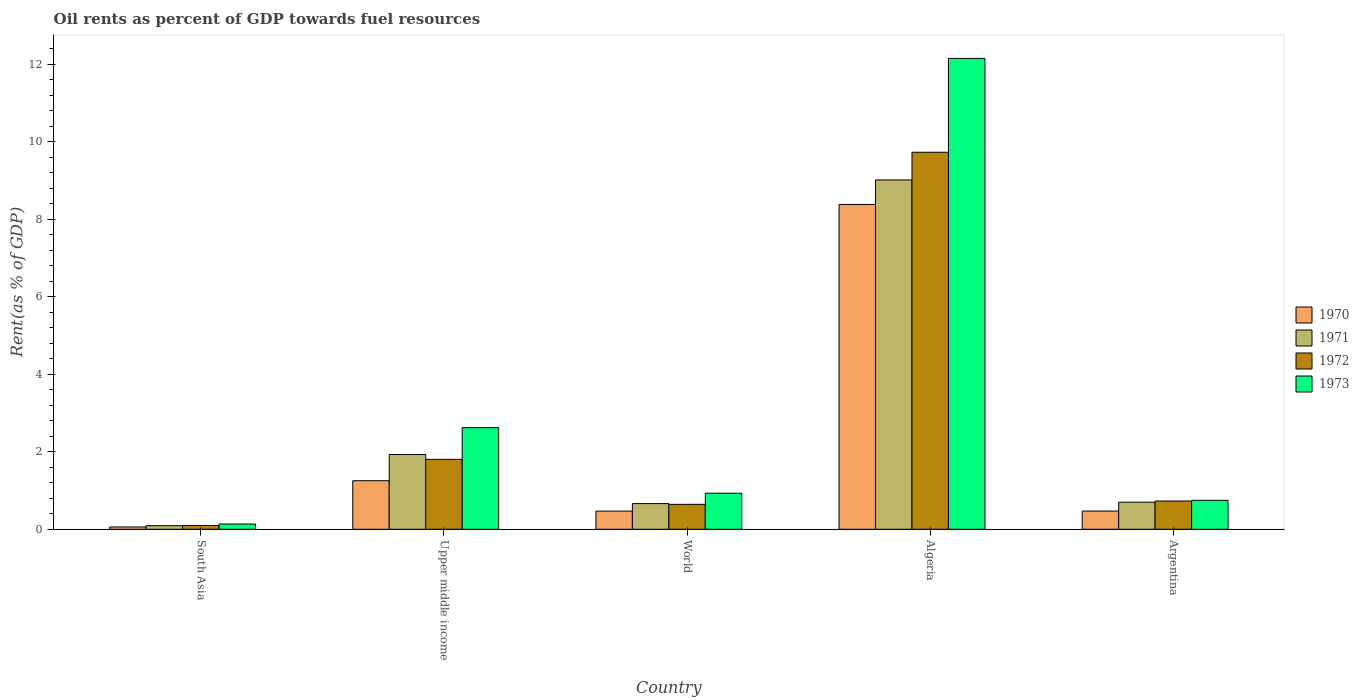What is the label of the 4th group of bars from the left?
Your response must be concise. Algeria. What is the oil rent in 1972 in South Asia?
Keep it short and to the point. 0.1. Across all countries, what is the maximum oil rent in 1973?
Offer a terse response. 12.15. Across all countries, what is the minimum oil rent in 1973?
Your response must be concise. 0.14. In which country was the oil rent in 1970 maximum?
Your response must be concise. Algeria. What is the total oil rent in 1972 in the graph?
Make the answer very short. 13.01. What is the difference between the oil rent in 1970 in Argentina and that in Upper middle income?
Make the answer very short. -0.78. What is the difference between the oil rent in 1971 in Argentina and the oil rent in 1973 in Algeria?
Provide a short and direct response. -11.45. What is the average oil rent in 1973 per country?
Offer a very short reply. 3.32. What is the difference between the oil rent of/in 1973 and oil rent of/in 1972 in South Asia?
Provide a short and direct response. 0.04. In how many countries, is the oil rent in 1972 greater than 4.4 %?
Offer a very short reply. 1. What is the ratio of the oil rent in 1971 in Algeria to that in Argentina?
Keep it short and to the point. 12.88. What is the difference between the highest and the second highest oil rent in 1971?
Provide a short and direct response. -8.32. What is the difference between the highest and the lowest oil rent in 1971?
Offer a terse response. 8.92. Is the sum of the oil rent in 1970 in Argentina and South Asia greater than the maximum oil rent in 1973 across all countries?
Provide a short and direct response. No. Is it the case that in every country, the sum of the oil rent in 1973 and oil rent in 1971 is greater than the sum of oil rent in 1972 and oil rent in 1970?
Provide a short and direct response. No. What does the 4th bar from the right in Algeria represents?
Your answer should be compact. 1970. How many bars are there?
Provide a succinct answer. 20. How many countries are there in the graph?
Provide a succinct answer. 5. What is the difference between two consecutive major ticks on the Y-axis?
Offer a very short reply. 2. Are the values on the major ticks of Y-axis written in scientific E-notation?
Keep it short and to the point. No. Does the graph contain any zero values?
Provide a short and direct response. No. Where does the legend appear in the graph?
Offer a very short reply. Center right. How many legend labels are there?
Provide a succinct answer. 4. How are the legend labels stacked?
Provide a short and direct response. Vertical. What is the title of the graph?
Ensure brevity in your answer.  Oil rents as percent of GDP towards fuel resources. What is the label or title of the Y-axis?
Provide a succinct answer. Rent(as % of GDP). What is the Rent(as % of GDP) in 1970 in South Asia?
Ensure brevity in your answer.  0.06. What is the Rent(as % of GDP) of 1971 in South Asia?
Your response must be concise. 0.09. What is the Rent(as % of GDP) of 1972 in South Asia?
Make the answer very short. 0.1. What is the Rent(as % of GDP) of 1973 in South Asia?
Keep it short and to the point. 0.14. What is the Rent(as % of GDP) in 1970 in Upper middle income?
Offer a terse response. 1.25. What is the Rent(as % of GDP) in 1971 in Upper middle income?
Ensure brevity in your answer.  1.93. What is the Rent(as % of GDP) in 1972 in Upper middle income?
Your answer should be very brief. 1.8. What is the Rent(as % of GDP) in 1973 in Upper middle income?
Offer a terse response. 2.62. What is the Rent(as % of GDP) of 1970 in World?
Provide a short and direct response. 0.47. What is the Rent(as % of GDP) in 1971 in World?
Keep it short and to the point. 0.66. What is the Rent(as % of GDP) of 1972 in World?
Ensure brevity in your answer.  0.64. What is the Rent(as % of GDP) of 1973 in World?
Make the answer very short. 0.93. What is the Rent(as % of GDP) in 1970 in Algeria?
Provide a short and direct response. 8.38. What is the Rent(as % of GDP) in 1971 in Algeria?
Offer a very short reply. 9.02. What is the Rent(as % of GDP) of 1972 in Algeria?
Provide a short and direct response. 9.73. What is the Rent(as % of GDP) in 1973 in Algeria?
Offer a very short reply. 12.15. What is the Rent(as % of GDP) of 1970 in Argentina?
Make the answer very short. 0.47. What is the Rent(as % of GDP) in 1971 in Argentina?
Offer a terse response. 0.7. What is the Rent(as % of GDP) in 1972 in Argentina?
Make the answer very short. 0.73. What is the Rent(as % of GDP) in 1973 in Argentina?
Provide a succinct answer. 0.75. Across all countries, what is the maximum Rent(as % of GDP) of 1970?
Provide a succinct answer. 8.38. Across all countries, what is the maximum Rent(as % of GDP) of 1971?
Your response must be concise. 9.02. Across all countries, what is the maximum Rent(as % of GDP) of 1972?
Keep it short and to the point. 9.73. Across all countries, what is the maximum Rent(as % of GDP) in 1973?
Your answer should be compact. 12.15. Across all countries, what is the minimum Rent(as % of GDP) of 1970?
Provide a succinct answer. 0.06. Across all countries, what is the minimum Rent(as % of GDP) of 1971?
Give a very brief answer. 0.09. Across all countries, what is the minimum Rent(as % of GDP) in 1972?
Keep it short and to the point. 0.1. Across all countries, what is the minimum Rent(as % of GDP) of 1973?
Your answer should be compact. 0.14. What is the total Rent(as % of GDP) in 1970 in the graph?
Ensure brevity in your answer.  10.64. What is the total Rent(as % of GDP) in 1971 in the graph?
Provide a succinct answer. 12.4. What is the total Rent(as % of GDP) of 1972 in the graph?
Ensure brevity in your answer.  13.01. What is the total Rent(as % of GDP) of 1973 in the graph?
Offer a very short reply. 16.59. What is the difference between the Rent(as % of GDP) of 1970 in South Asia and that in Upper middle income?
Make the answer very short. -1.19. What is the difference between the Rent(as % of GDP) in 1971 in South Asia and that in Upper middle income?
Provide a succinct answer. -1.84. What is the difference between the Rent(as % of GDP) of 1972 in South Asia and that in Upper middle income?
Provide a succinct answer. -1.71. What is the difference between the Rent(as % of GDP) in 1973 in South Asia and that in Upper middle income?
Your answer should be very brief. -2.49. What is the difference between the Rent(as % of GDP) of 1970 in South Asia and that in World?
Your answer should be very brief. -0.41. What is the difference between the Rent(as % of GDP) in 1971 in South Asia and that in World?
Your response must be concise. -0.57. What is the difference between the Rent(as % of GDP) in 1972 in South Asia and that in World?
Offer a very short reply. -0.55. What is the difference between the Rent(as % of GDP) in 1973 in South Asia and that in World?
Offer a very short reply. -0.8. What is the difference between the Rent(as % of GDP) of 1970 in South Asia and that in Algeria?
Make the answer very short. -8.32. What is the difference between the Rent(as % of GDP) in 1971 in South Asia and that in Algeria?
Your response must be concise. -8.92. What is the difference between the Rent(as % of GDP) in 1972 in South Asia and that in Algeria?
Ensure brevity in your answer.  -9.63. What is the difference between the Rent(as % of GDP) of 1973 in South Asia and that in Algeria?
Your answer should be very brief. -12.02. What is the difference between the Rent(as % of GDP) in 1970 in South Asia and that in Argentina?
Offer a terse response. -0.41. What is the difference between the Rent(as % of GDP) of 1971 in South Asia and that in Argentina?
Provide a succinct answer. -0.61. What is the difference between the Rent(as % of GDP) of 1972 in South Asia and that in Argentina?
Provide a succinct answer. -0.63. What is the difference between the Rent(as % of GDP) in 1973 in South Asia and that in Argentina?
Provide a short and direct response. -0.61. What is the difference between the Rent(as % of GDP) of 1970 in Upper middle income and that in World?
Provide a succinct answer. 0.78. What is the difference between the Rent(as % of GDP) in 1971 in Upper middle income and that in World?
Make the answer very short. 1.27. What is the difference between the Rent(as % of GDP) in 1972 in Upper middle income and that in World?
Provide a succinct answer. 1.16. What is the difference between the Rent(as % of GDP) in 1973 in Upper middle income and that in World?
Offer a very short reply. 1.69. What is the difference between the Rent(as % of GDP) of 1970 in Upper middle income and that in Algeria?
Provide a short and direct response. -7.13. What is the difference between the Rent(as % of GDP) in 1971 in Upper middle income and that in Algeria?
Ensure brevity in your answer.  -7.09. What is the difference between the Rent(as % of GDP) in 1972 in Upper middle income and that in Algeria?
Offer a very short reply. -7.93. What is the difference between the Rent(as % of GDP) of 1973 in Upper middle income and that in Algeria?
Your answer should be very brief. -9.53. What is the difference between the Rent(as % of GDP) of 1970 in Upper middle income and that in Argentina?
Make the answer very short. 0.78. What is the difference between the Rent(as % of GDP) in 1971 in Upper middle income and that in Argentina?
Offer a very short reply. 1.23. What is the difference between the Rent(as % of GDP) in 1972 in Upper middle income and that in Argentina?
Provide a short and direct response. 1.07. What is the difference between the Rent(as % of GDP) of 1973 in Upper middle income and that in Argentina?
Ensure brevity in your answer.  1.88. What is the difference between the Rent(as % of GDP) of 1970 in World and that in Algeria?
Provide a succinct answer. -7.91. What is the difference between the Rent(as % of GDP) of 1971 in World and that in Algeria?
Your answer should be very brief. -8.35. What is the difference between the Rent(as % of GDP) in 1972 in World and that in Algeria?
Your response must be concise. -9.09. What is the difference between the Rent(as % of GDP) in 1973 in World and that in Algeria?
Offer a terse response. -11.22. What is the difference between the Rent(as % of GDP) of 1970 in World and that in Argentina?
Keep it short and to the point. -0. What is the difference between the Rent(as % of GDP) in 1971 in World and that in Argentina?
Your answer should be very brief. -0.04. What is the difference between the Rent(as % of GDP) in 1972 in World and that in Argentina?
Offer a very short reply. -0.09. What is the difference between the Rent(as % of GDP) in 1973 in World and that in Argentina?
Provide a succinct answer. 0.18. What is the difference between the Rent(as % of GDP) of 1970 in Algeria and that in Argentina?
Provide a succinct answer. 7.91. What is the difference between the Rent(as % of GDP) of 1971 in Algeria and that in Argentina?
Ensure brevity in your answer.  8.32. What is the difference between the Rent(as % of GDP) in 1972 in Algeria and that in Argentina?
Your answer should be compact. 9. What is the difference between the Rent(as % of GDP) in 1973 in Algeria and that in Argentina?
Your answer should be very brief. 11.41. What is the difference between the Rent(as % of GDP) of 1970 in South Asia and the Rent(as % of GDP) of 1971 in Upper middle income?
Your response must be concise. -1.87. What is the difference between the Rent(as % of GDP) of 1970 in South Asia and the Rent(as % of GDP) of 1972 in Upper middle income?
Your answer should be very brief. -1.74. What is the difference between the Rent(as % of GDP) of 1970 in South Asia and the Rent(as % of GDP) of 1973 in Upper middle income?
Your answer should be compact. -2.56. What is the difference between the Rent(as % of GDP) in 1971 in South Asia and the Rent(as % of GDP) in 1972 in Upper middle income?
Your answer should be compact. -1.71. What is the difference between the Rent(as % of GDP) of 1971 in South Asia and the Rent(as % of GDP) of 1973 in Upper middle income?
Offer a terse response. -2.53. What is the difference between the Rent(as % of GDP) of 1972 in South Asia and the Rent(as % of GDP) of 1973 in Upper middle income?
Provide a short and direct response. -2.52. What is the difference between the Rent(as % of GDP) of 1970 in South Asia and the Rent(as % of GDP) of 1971 in World?
Your answer should be compact. -0.6. What is the difference between the Rent(as % of GDP) of 1970 in South Asia and the Rent(as % of GDP) of 1972 in World?
Make the answer very short. -0.58. What is the difference between the Rent(as % of GDP) of 1970 in South Asia and the Rent(as % of GDP) of 1973 in World?
Give a very brief answer. -0.87. What is the difference between the Rent(as % of GDP) of 1971 in South Asia and the Rent(as % of GDP) of 1972 in World?
Provide a succinct answer. -0.55. What is the difference between the Rent(as % of GDP) in 1971 in South Asia and the Rent(as % of GDP) in 1973 in World?
Keep it short and to the point. -0.84. What is the difference between the Rent(as % of GDP) of 1972 in South Asia and the Rent(as % of GDP) of 1973 in World?
Keep it short and to the point. -0.83. What is the difference between the Rent(as % of GDP) of 1970 in South Asia and the Rent(as % of GDP) of 1971 in Algeria?
Make the answer very short. -8.96. What is the difference between the Rent(as % of GDP) of 1970 in South Asia and the Rent(as % of GDP) of 1972 in Algeria?
Offer a terse response. -9.67. What is the difference between the Rent(as % of GDP) in 1970 in South Asia and the Rent(as % of GDP) in 1973 in Algeria?
Make the answer very short. -12.09. What is the difference between the Rent(as % of GDP) in 1971 in South Asia and the Rent(as % of GDP) in 1972 in Algeria?
Provide a succinct answer. -9.64. What is the difference between the Rent(as % of GDP) of 1971 in South Asia and the Rent(as % of GDP) of 1973 in Algeria?
Offer a very short reply. -12.06. What is the difference between the Rent(as % of GDP) in 1972 in South Asia and the Rent(as % of GDP) in 1973 in Algeria?
Ensure brevity in your answer.  -12.05. What is the difference between the Rent(as % of GDP) of 1970 in South Asia and the Rent(as % of GDP) of 1971 in Argentina?
Provide a succinct answer. -0.64. What is the difference between the Rent(as % of GDP) of 1970 in South Asia and the Rent(as % of GDP) of 1972 in Argentina?
Provide a short and direct response. -0.67. What is the difference between the Rent(as % of GDP) in 1970 in South Asia and the Rent(as % of GDP) in 1973 in Argentina?
Your answer should be compact. -0.69. What is the difference between the Rent(as % of GDP) of 1971 in South Asia and the Rent(as % of GDP) of 1972 in Argentina?
Offer a terse response. -0.64. What is the difference between the Rent(as % of GDP) of 1971 in South Asia and the Rent(as % of GDP) of 1973 in Argentina?
Make the answer very short. -0.65. What is the difference between the Rent(as % of GDP) in 1972 in South Asia and the Rent(as % of GDP) in 1973 in Argentina?
Keep it short and to the point. -0.65. What is the difference between the Rent(as % of GDP) in 1970 in Upper middle income and the Rent(as % of GDP) in 1971 in World?
Keep it short and to the point. 0.59. What is the difference between the Rent(as % of GDP) of 1970 in Upper middle income and the Rent(as % of GDP) of 1972 in World?
Provide a succinct answer. 0.61. What is the difference between the Rent(as % of GDP) in 1970 in Upper middle income and the Rent(as % of GDP) in 1973 in World?
Give a very brief answer. 0.32. What is the difference between the Rent(as % of GDP) of 1971 in Upper middle income and the Rent(as % of GDP) of 1972 in World?
Provide a short and direct response. 1.29. What is the difference between the Rent(as % of GDP) of 1971 in Upper middle income and the Rent(as % of GDP) of 1973 in World?
Offer a very short reply. 1. What is the difference between the Rent(as % of GDP) of 1972 in Upper middle income and the Rent(as % of GDP) of 1973 in World?
Your response must be concise. 0.87. What is the difference between the Rent(as % of GDP) in 1970 in Upper middle income and the Rent(as % of GDP) in 1971 in Algeria?
Provide a short and direct response. -7.76. What is the difference between the Rent(as % of GDP) of 1970 in Upper middle income and the Rent(as % of GDP) of 1972 in Algeria?
Your response must be concise. -8.48. What is the difference between the Rent(as % of GDP) of 1970 in Upper middle income and the Rent(as % of GDP) of 1973 in Algeria?
Your response must be concise. -10.9. What is the difference between the Rent(as % of GDP) in 1971 in Upper middle income and the Rent(as % of GDP) in 1973 in Algeria?
Keep it short and to the point. -10.22. What is the difference between the Rent(as % of GDP) in 1972 in Upper middle income and the Rent(as % of GDP) in 1973 in Algeria?
Provide a short and direct response. -10.35. What is the difference between the Rent(as % of GDP) in 1970 in Upper middle income and the Rent(as % of GDP) in 1971 in Argentina?
Keep it short and to the point. 0.55. What is the difference between the Rent(as % of GDP) of 1970 in Upper middle income and the Rent(as % of GDP) of 1972 in Argentina?
Give a very brief answer. 0.52. What is the difference between the Rent(as % of GDP) in 1970 in Upper middle income and the Rent(as % of GDP) in 1973 in Argentina?
Ensure brevity in your answer.  0.51. What is the difference between the Rent(as % of GDP) in 1971 in Upper middle income and the Rent(as % of GDP) in 1972 in Argentina?
Offer a terse response. 1.2. What is the difference between the Rent(as % of GDP) in 1971 in Upper middle income and the Rent(as % of GDP) in 1973 in Argentina?
Your answer should be very brief. 1.18. What is the difference between the Rent(as % of GDP) in 1972 in Upper middle income and the Rent(as % of GDP) in 1973 in Argentina?
Your answer should be compact. 1.06. What is the difference between the Rent(as % of GDP) of 1970 in World and the Rent(as % of GDP) of 1971 in Algeria?
Your answer should be very brief. -8.55. What is the difference between the Rent(as % of GDP) of 1970 in World and the Rent(as % of GDP) of 1972 in Algeria?
Ensure brevity in your answer.  -9.26. What is the difference between the Rent(as % of GDP) in 1970 in World and the Rent(as % of GDP) in 1973 in Algeria?
Make the answer very short. -11.68. What is the difference between the Rent(as % of GDP) of 1971 in World and the Rent(as % of GDP) of 1972 in Algeria?
Your answer should be compact. -9.07. What is the difference between the Rent(as % of GDP) of 1971 in World and the Rent(as % of GDP) of 1973 in Algeria?
Offer a terse response. -11.49. What is the difference between the Rent(as % of GDP) of 1972 in World and the Rent(as % of GDP) of 1973 in Algeria?
Offer a terse response. -11.51. What is the difference between the Rent(as % of GDP) of 1970 in World and the Rent(as % of GDP) of 1971 in Argentina?
Ensure brevity in your answer.  -0.23. What is the difference between the Rent(as % of GDP) in 1970 in World and the Rent(as % of GDP) in 1972 in Argentina?
Provide a succinct answer. -0.26. What is the difference between the Rent(as % of GDP) of 1970 in World and the Rent(as % of GDP) of 1973 in Argentina?
Your answer should be compact. -0.28. What is the difference between the Rent(as % of GDP) in 1971 in World and the Rent(as % of GDP) in 1972 in Argentina?
Ensure brevity in your answer.  -0.07. What is the difference between the Rent(as % of GDP) in 1971 in World and the Rent(as % of GDP) in 1973 in Argentina?
Provide a succinct answer. -0.08. What is the difference between the Rent(as % of GDP) of 1972 in World and the Rent(as % of GDP) of 1973 in Argentina?
Your response must be concise. -0.1. What is the difference between the Rent(as % of GDP) in 1970 in Algeria and the Rent(as % of GDP) in 1971 in Argentina?
Provide a short and direct response. 7.68. What is the difference between the Rent(as % of GDP) of 1970 in Algeria and the Rent(as % of GDP) of 1972 in Argentina?
Offer a very short reply. 7.65. What is the difference between the Rent(as % of GDP) in 1970 in Algeria and the Rent(as % of GDP) in 1973 in Argentina?
Provide a short and direct response. 7.64. What is the difference between the Rent(as % of GDP) of 1971 in Algeria and the Rent(as % of GDP) of 1972 in Argentina?
Offer a terse response. 8.29. What is the difference between the Rent(as % of GDP) in 1971 in Algeria and the Rent(as % of GDP) in 1973 in Argentina?
Offer a very short reply. 8.27. What is the difference between the Rent(as % of GDP) in 1972 in Algeria and the Rent(as % of GDP) in 1973 in Argentina?
Your response must be concise. 8.98. What is the average Rent(as % of GDP) in 1970 per country?
Your response must be concise. 2.13. What is the average Rent(as % of GDP) in 1971 per country?
Give a very brief answer. 2.48. What is the average Rent(as % of GDP) of 1972 per country?
Offer a very short reply. 2.6. What is the average Rent(as % of GDP) in 1973 per country?
Give a very brief answer. 3.32. What is the difference between the Rent(as % of GDP) of 1970 and Rent(as % of GDP) of 1971 in South Asia?
Your answer should be compact. -0.03. What is the difference between the Rent(as % of GDP) of 1970 and Rent(as % of GDP) of 1972 in South Asia?
Make the answer very short. -0.04. What is the difference between the Rent(as % of GDP) of 1970 and Rent(as % of GDP) of 1973 in South Asia?
Offer a terse response. -0.08. What is the difference between the Rent(as % of GDP) in 1971 and Rent(as % of GDP) in 1972 in South Asia?
Ensure brevity in your answer.  -0.01. What is the difference between the Rent(as % of GDP) of 1971 and Rent(as % of GDP) of 1973 in South Asia?
Your answer should be compact. -0.04. What is the difference between the Rent(as % of GDP) of 1972 and Rent(as % of GDP) of 1973 in South Asia?
Offer a very short reply. -0.04. What is the difference between the Rent(as % of GDP) of 1970 and Rent(as % of GDP) of 1971 in Upper middle income?
Your response must be concise. -0.68. What is the difference between the Rent(as % of GDP) of 1970 and Rent(as % of GDP) of 1972 in Upper middle income?
Offer a terse response. -0.55. What is the difference between the Rent(as % of GDP) of 1970 and Rent(as % of GDP) of 1973 in Upper middle income?
Your answer should be very brief. -1.37. What is the difference between the Rent(as % of GDP) in 1971 and Rent(as % of GDP) in 1972 in Upper middle income?
Offer a terse response. 0.13. What is the difference between the Rent(as % of GDP) of 1971 and Rent(as % of GDP) of 1973 in Upper middle income?
Offer a very short reply. -0.69. What is the difference between the Rent(as % of GDP) in 1972 and Rent(as % of GDP) in 1973 in Upper middle income?
Offer a very short reply. -0.82. What is the difference between the Rent(as % of GDP) in 1970 and Rent(as % of GDP) in 1971 in World?
Make the answer very short. -0.19. What is the difference between the Rent(as % of GDP) in 1970 and Rent(as % of GDP) in 1972 in World?
Your answer should be very brief. -0.17. What is the difference between the Rent(as % of GDP) in 1970 and Rent(as % of GDP) in 1973 in World?
Your response must be concise. -0.46. What is the difference between the Rent(as % of GDP) of 1971 and Rent(as % of GDP) of 1972 in World?
Your answer should be compact. 0.02. What is the difference between the Rent(as % of GDP) in 1971 and Rent(as % of GDP) in 1973 in World?
Your answer should be very brief. -0.27. What is the difference between the Rent(as % of GDP) in 1972 and Rent(as % of GDP) in 1973 in World?
Provide a succinct answer. -0.29. What is the difference between the Rent(as % of GDP) of 1970 and Rent(as % of GDP) of 1971 in Algeria?
Give a very brief answer. -0.63. What is the difference between the Rent(as % of GDP) of 1970 and Rent(as % of GDP) of 1972 in Algeria?
Keep it short and to the point. -1.35. What is the difference between the Rent(as % of GDP) of 1970 and Rent(as % of GDP) of 1973 in Algeria?
Your answer should be compact. -3.77. What is the difference between the Rent(as % of GDP) of 1971 and Rent(as % of GDP) of 1972 in Algeria?
Offer a terse response. -0.71. What is the difference between the Rent(as % of GDP) in 1971 and Rent(as % of GDP) in 1973 in Algeria?
Provide a short and direct response. -3.14. What is the difference between the Rent(as % of GDP) of 1972 and Rent(as % of GDP) of 1973 in Algeria?
Keep it short and to the point. -2.42. What is the difference between the Rent(as % of GDP) in 1970 and Rent(as % of GDP) in 1971 in Argentina?
Give a very brief answer. -0.23. What is the difference between the Rent(as % of GDP) in 1970 and Rent(as % of GDP) in 1972 in Argentina?
Ensure brevity in your answer.  -0.26. What is the difference between the Rent(as % of GDP) of 1970 and Rent(as % of GDP) of 1973 in Argentina?
Your answer should be compact. -0.28. What is the difference between the Rent(as % of GDP) of 1971 and Rent(as % of GDP) of 1972 in Argentina?
Your response must be concise. -0.03. What is the difference between the Rent(as % of GDP) in 1971 and Rent(as % of GDP) in 1973 in Argentina?
Ensure brevity in your answer.  -0.05. What is the difference between the Rent(as % of GDP) of 1972 and Rent(as % of GDP) of 1973 in Argentina?
Offer a terse response. -0.02. What is the ratio of the Rent(as % of GDP) of 1970 in South Asia to that in Upper middle income?
Ensure brevity in your answer.  0.05. What is the ratio of the Rent(as % of GDP) in 1971 in South Asia to that in Upper middle income?
Ensure brevity in your answer.  0.05. What is the ratio of the Rent(as % of GDP) of 1972 in South Asia to that in Upper middle income?
Your answer should be compact. 0.05. What is the ratio of the Rent(as % of GDP) in 1973 in South Asia to that in Upper middle income?
Your answer should be very brief. 0.05. What is the ratio of the Rent(as % of GDP) of 1970 in South Asia to that in World?
Your answer should be very brief. 0.13. What is the ratio of the Rent(as % of GDP) of 1971 in South Asia to that in World?
Give a very brief answer. 0.14. What is the ratio of the Rent(as % of GDP) in 1972 in South Asia to that in World?
Give a very brief answer. 0.15. What is the ratio of the Rent(as % of GDP) in 1973 in South Asia to that in World?
Give a very brief answer. 0.14. What is the ratio of the Rent(as % of GDP) in 1970 in South Asia to that in Algeria?
Offer a very short reply. 0.01. What is the ratio of the Rent(as % of GDP) in 1971 in South Asia to that in Algeria?
Your response must be concise. 0.01. What is the ratio of the Rent(as % of GDP) of 1972 in South Asia to that in Algeria?
Your answer should be compact. 0.01. What is the ratio of the Rent(as % of GDP) in 1973 in South Asia to that in Algeria?
Ensure brevity in your answer.  0.01. What is the ratio of the Rent(as % of GDP) in 1970 in South Asia to that in Argentina?
Your answer should be very brief. 0.13. What is the ratio of the Rent(as % of GDP) of 1971 in South Asia to that in Argentina?
Your response must be concise. 0.13. What is the ratio of the Rent(as % of GDP) in 1972 in South Asia to that in Argentina?
Offer a very short reply. 0.14. What is the ratio of the Rent(as % of GDP) in 1973 in South Asia to that in Argentina?
Offer a terse response. 0.18. What is the ratio of the Rent(as % of GDP) in 1970 in Upper middle income to that in World?
Provide a succinct answer. 2.67. What is the ratio of the Rent(as % of GDP) of 1971 in Upper middle income to that in World?
Make the answer very short. 2.91. What is the ratio of the Rent(as % of GDP) of 1972 in Upper middle income to that in World?
Your answer should be very brief. 2.8. What is the ratio of the Rent(as % of GDP) in 1973 in Upper middle income to that in World?
Ensure brevity in your answer.  2.82. What is the ratio of the Rent(as % of GDP) of 1970 in Upper middle income to that in Algeria?
Give a very brief answer. 0.15. What is the ratio of the Rent(as % of GDP) of 1971 in Upper middle income to that in Algeria?
Give a very brief answer. 0.21. What is the ratio of the Rent(as % of GDP) in 1972 in Upper middle income to that in Algeria?
Your answer should be compact. 0.19. What is the ratio of the Rent(as % of GDP) in 1973 in Upper middle income to that in Algeria?
Make the answer very short. 0.22. What is the ratio of the Rent(as % of GDP) of 1970 in Upper middle income to that in Argentina?
Ensure brevity in your answer.  2.67. What is the ratio of the Rent(as % of GDP) of 1971 in Upper middle income to that in Argentina?
Make the answer very short. 2.76. What is the ratio of the Rent(as % of GDP) of 1972 in Upper middle income to that in Argentina?
Make the answer very short. 2.47. What is the ratio of the Rent(as % of GDP) in 1973 in Upper middle income to that in Argentina?
Make the answer very short. 3.51. What is the ratio of the Rent(as % of GDP) in 1970 in World to that in Algeria?
Provide a succinct answer. 0.06. What is the ratio of the Rent(as % of GDP) in 1971 in World to that in Algeria?
Keep it short and to the point. 0.07. What is the ratio of the Rent(as % of GDP) of 1972 in World to that in Algeria?
Your response must be concise. 0.07. What is the ratio of the Rent(as % of GDP) in 1973 in World to that in Algeria?
Provide a short and direct response. 0.08. What is the ratio of the Rent(as % of GDP) in 1971 in World to that in Argentina?
Make the answer very short. 0.95. What is the ratio of the Rent(as % of GDP) of 1972 in World to that in Argentina?
Your answer should be very brief. 0.88. What is the ratio of the Rent(as % of GDP) in 1973 in World to that in Argentina?
Give a very brief answer. 1.25. What is the ratio of the Rent(as % of GDP) of 1970 in Algeria to that in Argentina?
Your response must be concise. 17.83. What is the ratio of the Rent(as % of GDP) of 1971 in Algeria to that in Argentina?
Provide a short and direct response. 12.88. What is the ratio of the Rent(as % of GDP) in 1972 in Algeria to that in Argentina?
Ensure brevity in your answer.  13.33. What is the ratio of the Rent(as % of GDP) in 1973 in Algeria to that in Argentina?
Make the answer very short. 16.27. What is the difference between the highest and the second highest Rent(as % of GDP) in 1970?
Ensure brevity in your answer.  7.13. What is the difference between the highest and the second highest Rent(as % of GDP) of 1971?
Give a very brief answer. 7.09. What is the difference between the highest and the second highest Rent(as % of GDP) in 1972?
Provide a short and direct response. 7.93. What is the difference between the highest and the second highest Rent(as % of GDP) of 1973?
Provide a succinct answer. 9.53. What is the difference between the highest and the lowest Rent(as % of GDP) of 1970?
Your answer should be compact. 8.32. What is the difference between the highest and the lowest Rent(as % of GDP) in 1971?
Your answer should be compact. 8.92. What is the difference between the highest and the lowest Rent(as % of GDP) in 1972?
Your response must be concise. 9.63. What is the difference between the highest and the lowest Rent(as % of GDP) in 1973?
Provide a short and direct response. 12.02. 